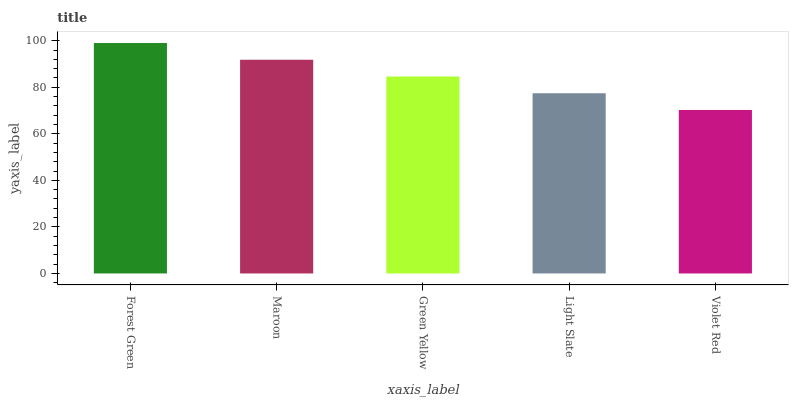Is Violet Red the minimum?
Answer yes or no. Yes. Is Forest Green the maximum?
Answer yes or no. Yes. Is Maroon the minimum?
Answer yes or no. No. Is Maroon the maximum?
Answer yes or no. No. Is Forest Green greater than Maroon?
Answer yes or no. Yes. Is Maroon less than Forest Green?
Answer yes or no. Yes. Is Maroon greater than Forest Green?
Answer yes or no. No. Is Forest Green less than Maroon?
Answer yes or no. No. Is Green Yellow the high median?
Answer yes or no. Yes. Is Green Yellow the low median?
Answer yes or no. Yes. Is Forest Green the high median?
Answer yes or no. No. Is Light Slate the low median?
Answer yes or no. No. 